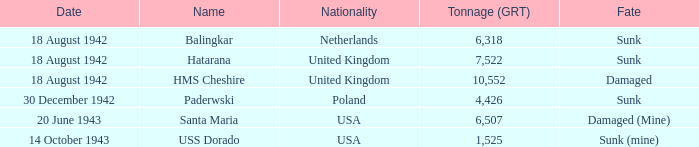From which country does the hms cheshire originate? United Kingdom. 